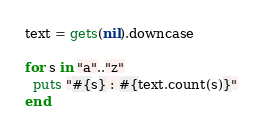Convert code to text. <code><loc_0><loc_0><loc_500><loc_500><_Ruby_>text = gets(nil).downcase

for s in "a".."z"
  puts "#{s} : #{text.count(s)}"
end

</code> 